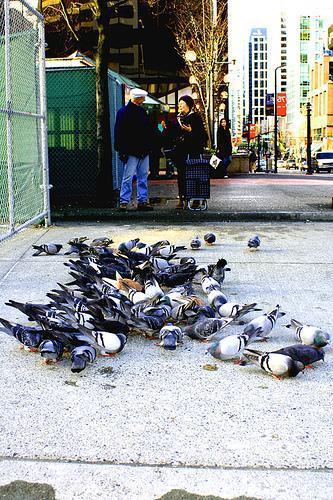How many people are there?
Give a very brief answer. 2. 